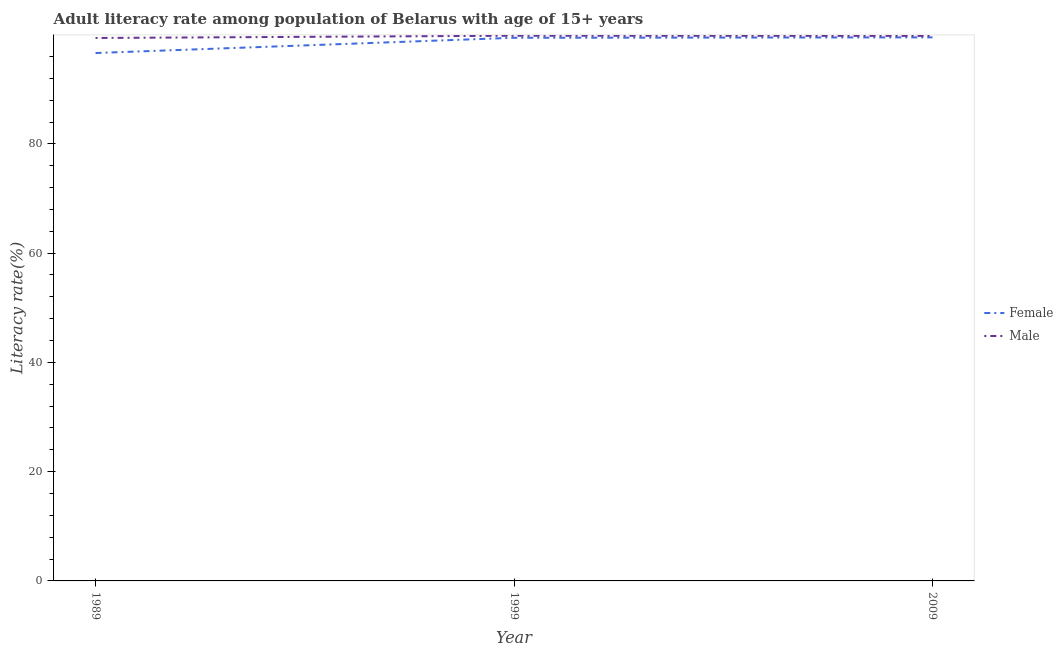How many different coloured lines are there?
Offer a terse response. 2. Is the number of lines equal to the number of legend labels?
Ensure brevity in your answer.  Yes. What is the female adult literacy rate in 1999?
Your answer should be compact. 99.42. Across all years, what is the maximum male adult literacy rate?
Your answer should be compact. 99.79. Across all years, what is the minimum female adult literacy rate?
Make the answer very short. 96.63. In which year was the female adult literacy rate maximum?
Your response must be concise. 2009. What is the total female adult literacy rate in the graph?
Your answer should be very brief. 295.54. What is the difference between the male adult literacy rate in 1999 and that in 2009?
Make the answer very short. 0.03. What is the difference between the female adult literacy rate in 1989 and the male adult literacy rate in 1999?
Keep it short and to the point. -3.16. What is the average male adult literacy rate per year?
Make the answer very short. 99.65. In the year 1999, what is the difference between the male adult literacy rate and female adult literacy rate?
Keep it short and to the point. 0.37. What is the ratio of the male adult literacy rate in 1999 to that in 2009?
Keep it short and to the point. 1. Is the difference between the female adult literacy rate in 1999 and 2009 greater than the difference between the male adult literacy rate in 1999 and 2009?
Give a very brief answer. No. What is the difference between the highest and the second highest female adult literacy rate?
Offer a terse response. 0.07. What is the difference between the highest and the lowest male adult literacy rate?
Your answer should be compact. 0.41. In how many years, is the male adult literacy rate greater than the average male adult literacy rate taken over all years?
Your answer should be compact. 2. Is the sum of the female adult literacy rate in 1989 and 2009 greater than the maximum male adult literacy rate across all years?
Ensure brevity in your answer.  Yes. Does the male adult literacy rate monotonically increase over the years?
Give a very brief answer. No. Is the male adult literacy rate strictly greater than the female adult literacy rate over the years?
Provide a succinct answer. Yes. What is the difference between two consecutive major ticks on the Y-axis?
Give a very brief answer. 20. Are the values on the major ticks of Y-axis written in scientific E-notation?
Make the answer very short. No. Does the graph contain any zero values?
Offer a very short reply. No. Where does the legend appear in the graph?
Provide a short and direct response. Center right. How many legend labels are there?
Provide a short and direct response. 2. What is the title of the graph?
Make the answer very short. Adult literacy rate among population of Belarus with age of 15+ years. What is the label or title of the X-axis?
Make the answer very short. Year. What is the label or title of the Y-axis?
Keep it short and to the point. Literacy rate(%). What is the Literacy rate(%) in Female in 1989?
Provide a succinct answer. 96.63. What is the Literacy rate(%) in Male in 1989?
Offer a terse response. 99.38. What is the Literacy rate(%) in Female in 1999?
Keep it short and to the point. 99.42. What is the Literacy rate(%) of Male in 1999?
Keep it short and to the point. 99.79. What is the Literacy rate(%) in Female in 2009?
Give a very brief answer. 99.49. What is the Literacy rate(%) in Male in 2009?
Provide a short and direct response. 99.76. Across all years, what is the maximum Literacy rate(%) in Female?
Ensure brevity in your answer.  99.49. Across all years, what is the maximum Literacy rate(%) in Male?
Provide a short and direct response. 99.79. Across all years, what is the minimum Literacy rate(%) in Female?
Your answer should be very brief. 96.63. Across all years, what is the minimum Literacy rate(%) in Male?
Offer a terse response. 99.38. What is the total Literacy rate(%) in Female in the graph?
Offer a very short reply. 295.54. What is the total Literacy rate(%) of Male in the graph?
Offer a very short reply. 298.94. What is the difference between the Literacy rate(%) in Female in 1989 and that in 1999?
Your response must be concise. -2.79. What is the difference between the Literacy rate(%) in Male in 1989 and that in 1999?
Your answer should be very brief. -0.41. What is the difference between the Literacy rate(%) of Female in 1989 and that in 2009?
Provide a short and direct response. -2.87. What is the difference between the Literacy rate(%) in Male in 1989 and that in 2009?
Keep it short and to the point. -0.38. What is the difference between the Literacy rate(%) in Female in 1999 and that in 2009?
Provide a succinct answer. -0.07. What is the difference between the Literacy rate(%) in Male in 1999 and that in 2009?
Ensure brevity in your answer.  0.03. What is the difference between the Literacy rate(%) in Female in 1989 and the Literacy rate(%) in Male in 1999?
Offer a terse response. -3.16. What is the difference between the Literacy rate(%) of Female in 1989 and the Literacy rate(%) of Male in 2009?
Offer a very short reply. -3.14. What is the difference between the Literacy rate(%) in Female in 1999 and the Literacy rate(%) in Male in 2009?
Provide a succinct answer. -0.34. What is the average Literacy rate(%) in Female per year?
Ensure brevity in your answer.  98.51. What is the average Literacy rate(%) in Male per year?
Provide a short and direct response. 99.65. In the year 1989, what is the difference between the Literacy rate(%) of Female and Literacy rate(%) of Male?
Offer a terse response. -2.76. In the year 1999, what is the difference between the Literacy rate(%) of Female and Literacy rate(%) of Male?
Keep it short and to the point. -0.37. In the year 2009, what is the difference between the Literacy rate(%) in Female and Literacy rate(%) in Male?
Your answer should be very brief. -0.27. What is the ratio of the Literacy rate(%) in Female in 1989 to that in 1999?
Your answer should be very brief. 0.97. What is the ratio of the Literacy rate(%) in Male in 1989 to that in 1999?
Offer a very short reply. 1. What is the ratio of the Literacy rate(%) of Female in 1989 to that in 2009?
Keep it short and to the point. 0.97. What is the ratio of the Literacy rate(%) of Female in 1999 to that in 2009?
Your response must be concise. 1. What is the ratio of the Literacy rate(%) of Male in 1999 to that in 2009?
Keep it short and to the point. 1. What is the difference between the highest and the second highest Literacy rate(%) of Female?
Your answer should be compact. 0.07. What is the difference between the highest and the second highest Literacy rate(%) of Male?
Your response must be concise. 0.03. What is the difference between the highest and the lowest Literacy rate(%) in Female?
Make the answer very short. 2.87. What is the difference between the highest and the lowest Literacy rate(%) of Male?
Give a very brief answer. 0.41. 